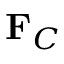<formula> <loc_0><loc_0><loc_500><loc_500>F _ { C }</formula> 